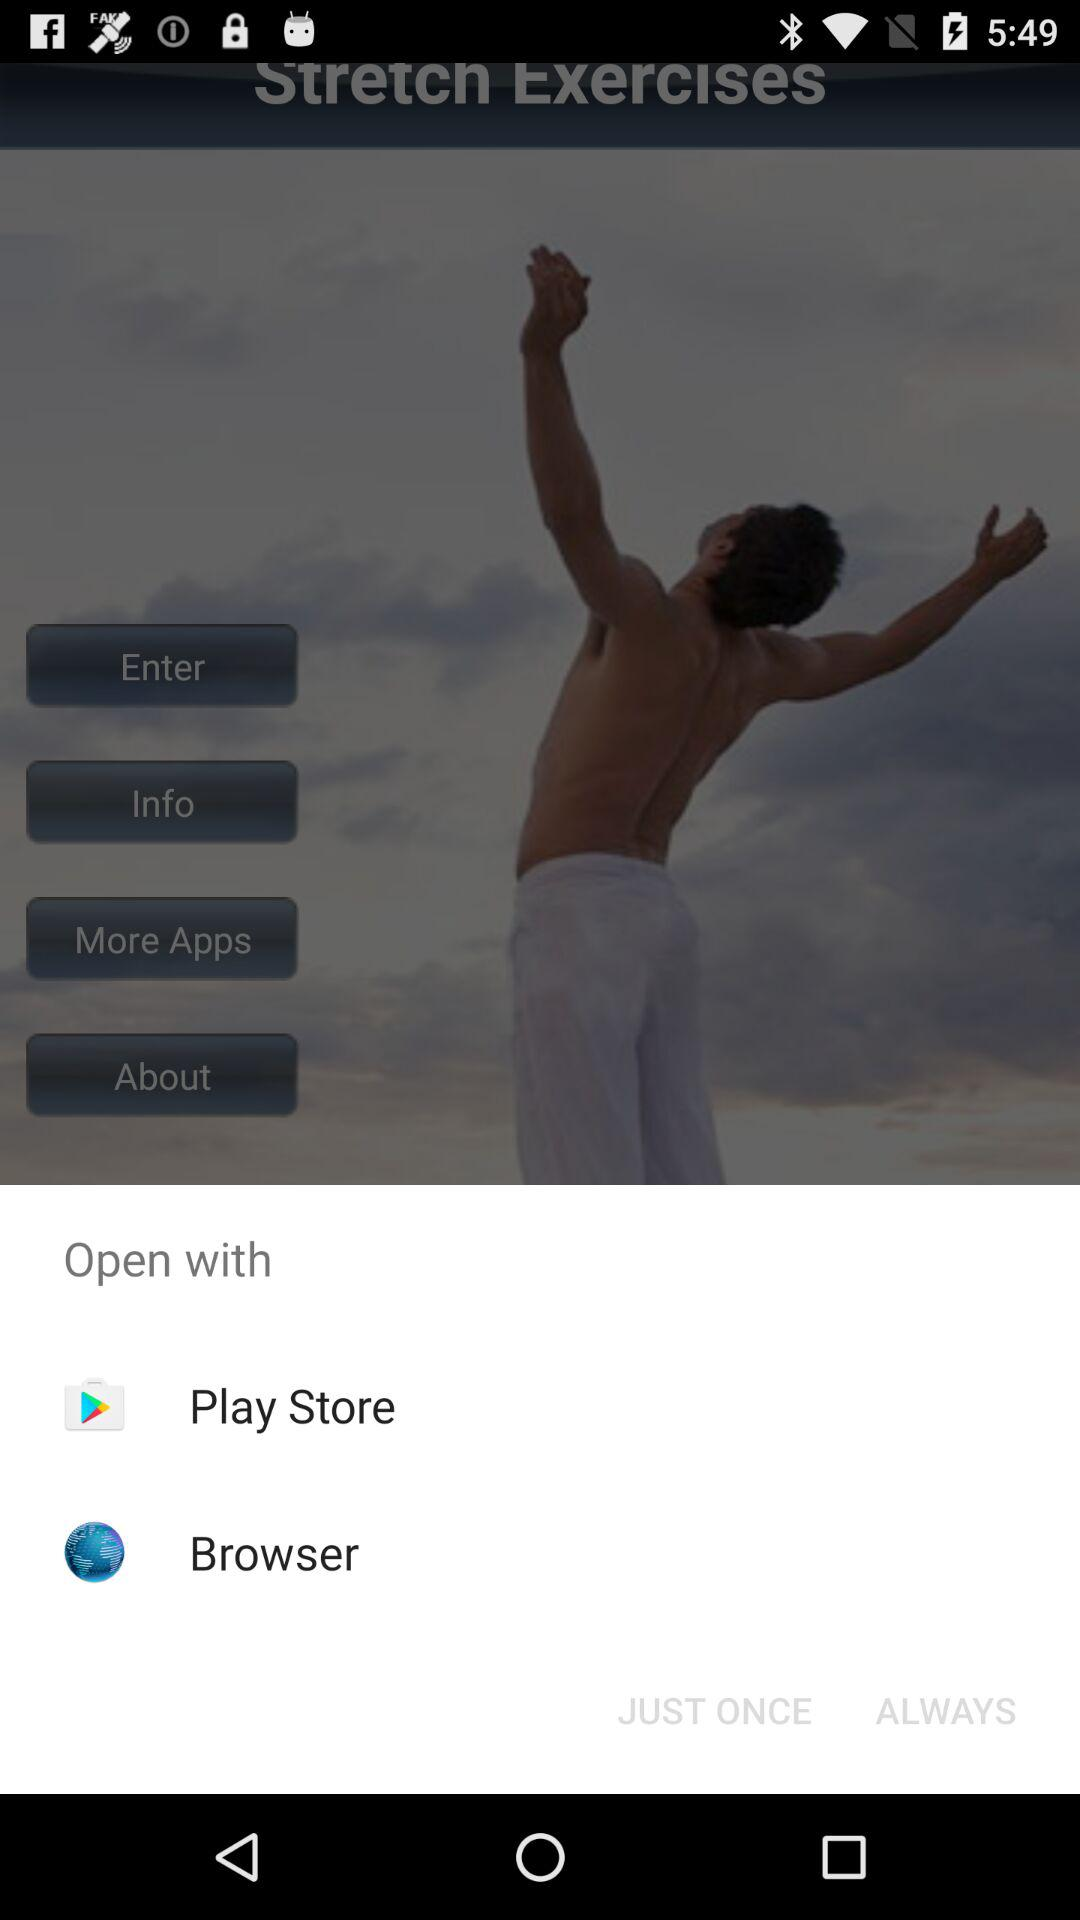What are the options that may be used to open the application? The options that may be used to open the application are "Play Store" and "Browser". 